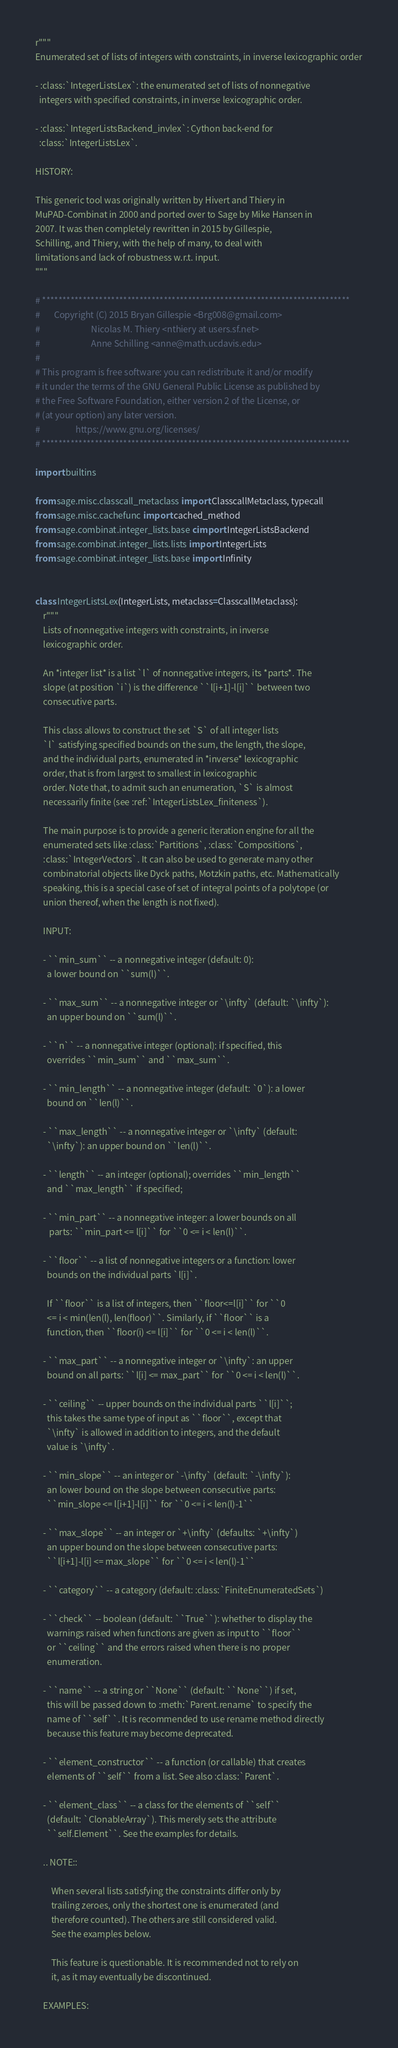<code> <loc_0><loc_0><loc_500><loc_500><_Cython_>r"""
Enumerated set of lists of integers with constraints, in inverse lexicographic order

- :class:`IntegerListsLex`: the enumerated set of lists of nonnegative
  integers with specified constraints, in inverse lexicographic order.

- :class:`IntegerListsBackend_invlex`: Cython back-end for
  :class:`IntegerListsLex`.

HISTORY:

This generic tool was originally written by Hivert and Thiery in
MuPAD-Combinat in 2000 and ported over to Sage by Mike Hansen in
2007. It was then completely rewritten in 2015 by Gillespie,
Schilling, and Thiery, with the help of many, to deal with
limitations and lack of robustness w.r.t. input.
"""

# ****************************************************************************
#       Copyright (C) 2015 Bryan Gillespie <Brg008@gmail.com>
#                          Nicolas M. Thiery <nthiery at users.sf.net>
#                          Anne Schilling <anne@math.ucdavis.edu>
#
# This program is free software: you can redistribute it and/or modify
# it under the terms of the GNU General Public License as published by
# the Free Software Foundation, either version 2 of the License, or
# (at your option) any later version.
#                  https://www.gnu.org/licenses/
# ****************************************************************************

import builtins

from sage.misc.classcall_metaclass import ClasscallMetaclass, typecall
from sage.misc.cachefunc import cached_method
from sage.combinat.integer_lists.base cimport IntegerListsBackend
from sage.combinat.integer_lists.lists import IntegerLists
from sage.combinat.integer_lists.base import Infinity


class IntegerListsLex(IntegerLists, metaclass=ClasscallMetaclass):
    r"""
    Lists of nonnegative integers with constraints, in inverse
    lexicographic order.

    An *integer list* is a list `l` of nonnegative integers, its *parts*. The
    slope (at position `i`) is the difference ``l[i+1]-l[i]`` between two
    consecutive parts.

    This class allows to construct the set `S` of all integer lists
    `l` satisfying specified bounds on the sum, the length, the slope,
    and the individual parts, enumerated in *inverse* lexicographic
    order, that is from largest to smallest in lexicographic
    order. Note that, to admit such an enumeration, `S` is almost
    necessarily finite (see :ref:`IntegerListsLex_finiteness`).

    The main purpose is to provide a generic iteration engine for all the
    enumerated sets like :class:`Partitions`, :class:`Compositions`,
    :class:`IntegerVectors`. It can also be used to generate many other
    combinatorial objects like Dyck paths, Motzkin paths, etc. Mathematically
    speaking, this is a special case of set of integral points of a polytope (or
    union thereof, when the length is not fixed).

    INPUT:

    - ``min_sum`` -- a nonnegative integer (default: 0):
      a lower bound on ``sum(l)``.

    - ``max_sum`` -- a nonnegative integer or `\infty` (default: `\infty`):
      an upper bound on ``sum(l)``.

    - ``n`` -- a nonnegative integer (optional): if specified, this
      overrides ``min_sum`` and ``max_sum``.

    - ``min_length`` -- a nonnegative integer (default: `0`): a lower
      bound on ``len(l)``.

    - ``max_length`` -- a nonnegative integer or `\infty` (default:
      `\infty`): an upper bound on ``len(l)``.

    - ``length`` -- an integer (optional); overrides ``min_length``
      and ``max_length`` if specified;

    - ``min_part`` -- a nonnegative integer: a lower bounds on all
       parts: ``min_part <= l[i]`` for ``0 <= i < len(l)``.

    - ``floor`` -- a list of nonnegative integers or a function: lower
      bounds on the individual parts `l[i]`.

      If ``floor`` is a list of integers, then ``floor<=l[i]`` for ``0
      <= i < min(len(l), len(floor)``. Similarly, if ``floor`` is a
      function, then ``floor(i) <= l[i]`` for ``0 <= i < len(l)``.

    - ``max_part`` -- a nonnegative integer or `\infty`: an upper
      bound on all parts: ``l[i] <= max_part`` for ``0 <= i < len(l)``.

    - ``ceiling`` -- upper bounds on the individual parts ``l[i]``;
      this takes the same type of input as ``floor``, except that
      `\infty` is allowed in addition to integers, and the default
      value is `\infty`.

    - ``min_slope`` -- an integer or `-\infty` (default: `-\infty`):
      an lower bound on the slope between consecutive parts:
      ``min_slope <= l[i+1]-l[i]`` for ``0 <= i < len(l)-1``

    - ``max_slope`` -- an integer or `+\infty` (defaults: `+\infty`)
      an upper bound on the slope between consecutive parts:
      ``l[i+1]-l[i] <= max_slope`` for ``0 <= i < len(l)-1``

    - ``category`` -- a category (default: :class:`FiniteEnumeratedSets`)

    - ``check`` -- boolean (default: ``True``): whether to display the
      warnings raised when functions are given as input to ``floor``
      or ``ceiling`` and the errors raised when there is no proper
      enumeration.

    - ``name`` -- a string or ``None`` (default: ``None``) if set,
      this will be passed down to :meth:`Parent.rename` to specify the
      name of ``self``. It is recommended to use rename method directly
      because this feature may become deprecated.

    - ``element_constructor`` -- a function (or callable) that creates
      elements of ``self`` from a list. See also :class:`Parent`.

    - ``element_class`` -- a class for the elements of ``self``
      (default: `ClonableArray`). This merely sets the attribute
      ``self.Element``. See the examples for details.

    .. NOTE::

        When several lists satisfying the constraints differ only by
        trailing zeroes, only the shortest one is enumerated (and
        therefore counted). The others are still considered valid.
        See the examples below.

        This feature is questionable. It is recommended not to rely on
        it, as it may eventually be discontinued.

    EXAMPLES:
</code> 